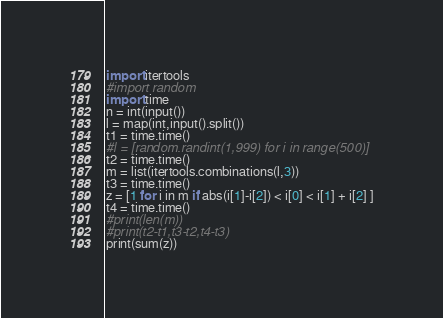<code> <loc_0><loc_0><loc_500><loc_500><_Python_>import itertools
#import random
import time
n = int(input())
l = map(int,input().split())
t1 = time.time()
#l = [random.randint(1,999) for i in range(500)]
t2 = time.time()
m = list(itertools.combinations(l,3))
t3 = time.time()
z = [1 for i in m if abs(i[1]-i[2]) < i[0] < i[1] + i[2] ]
t4 = time.time()
#print(len(m))
#print(t2-t1,t3-t2,t4-t3)
print(sum(z))</code> 